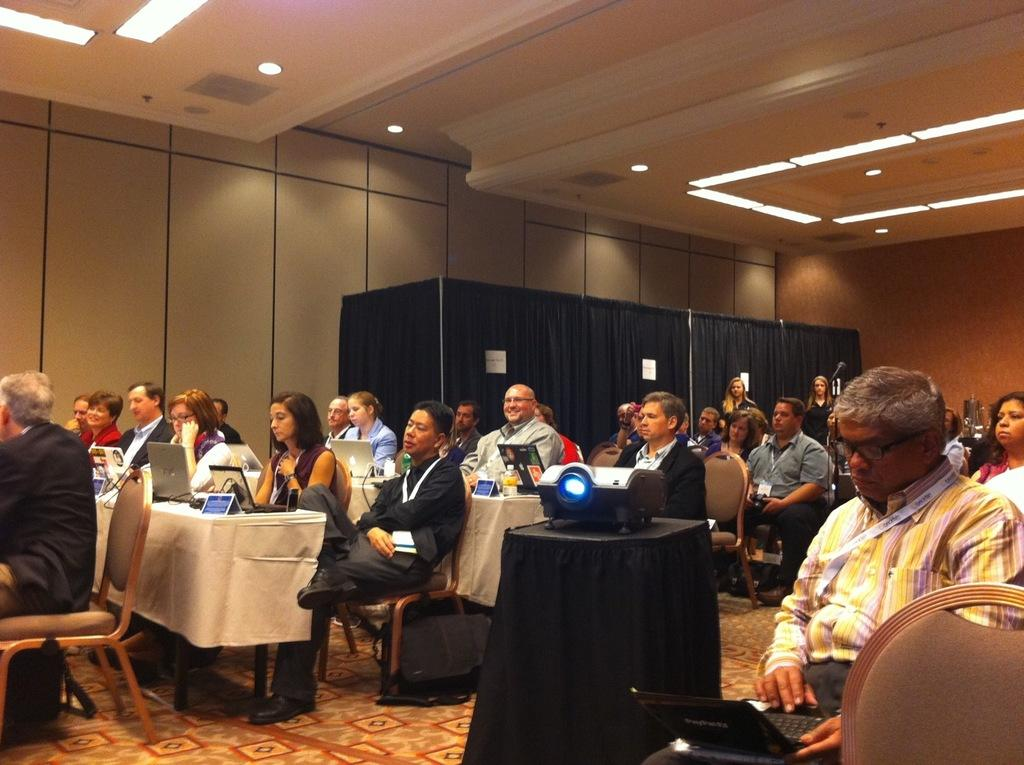What are the people in the image doing? There is a group of people sitting on chairs in the image. What electronic device can be seen in the image? There is a laptop in the image. What is placed on the table in the image? There is a projector placed on a table in the image. How many cats are sitting on the chairs with the people in the image? There are no cats present in the image; it only shows a group of people sitting on chairs. What type of wool is being used by the boys in the image? There are no boys or wool present in the image. 